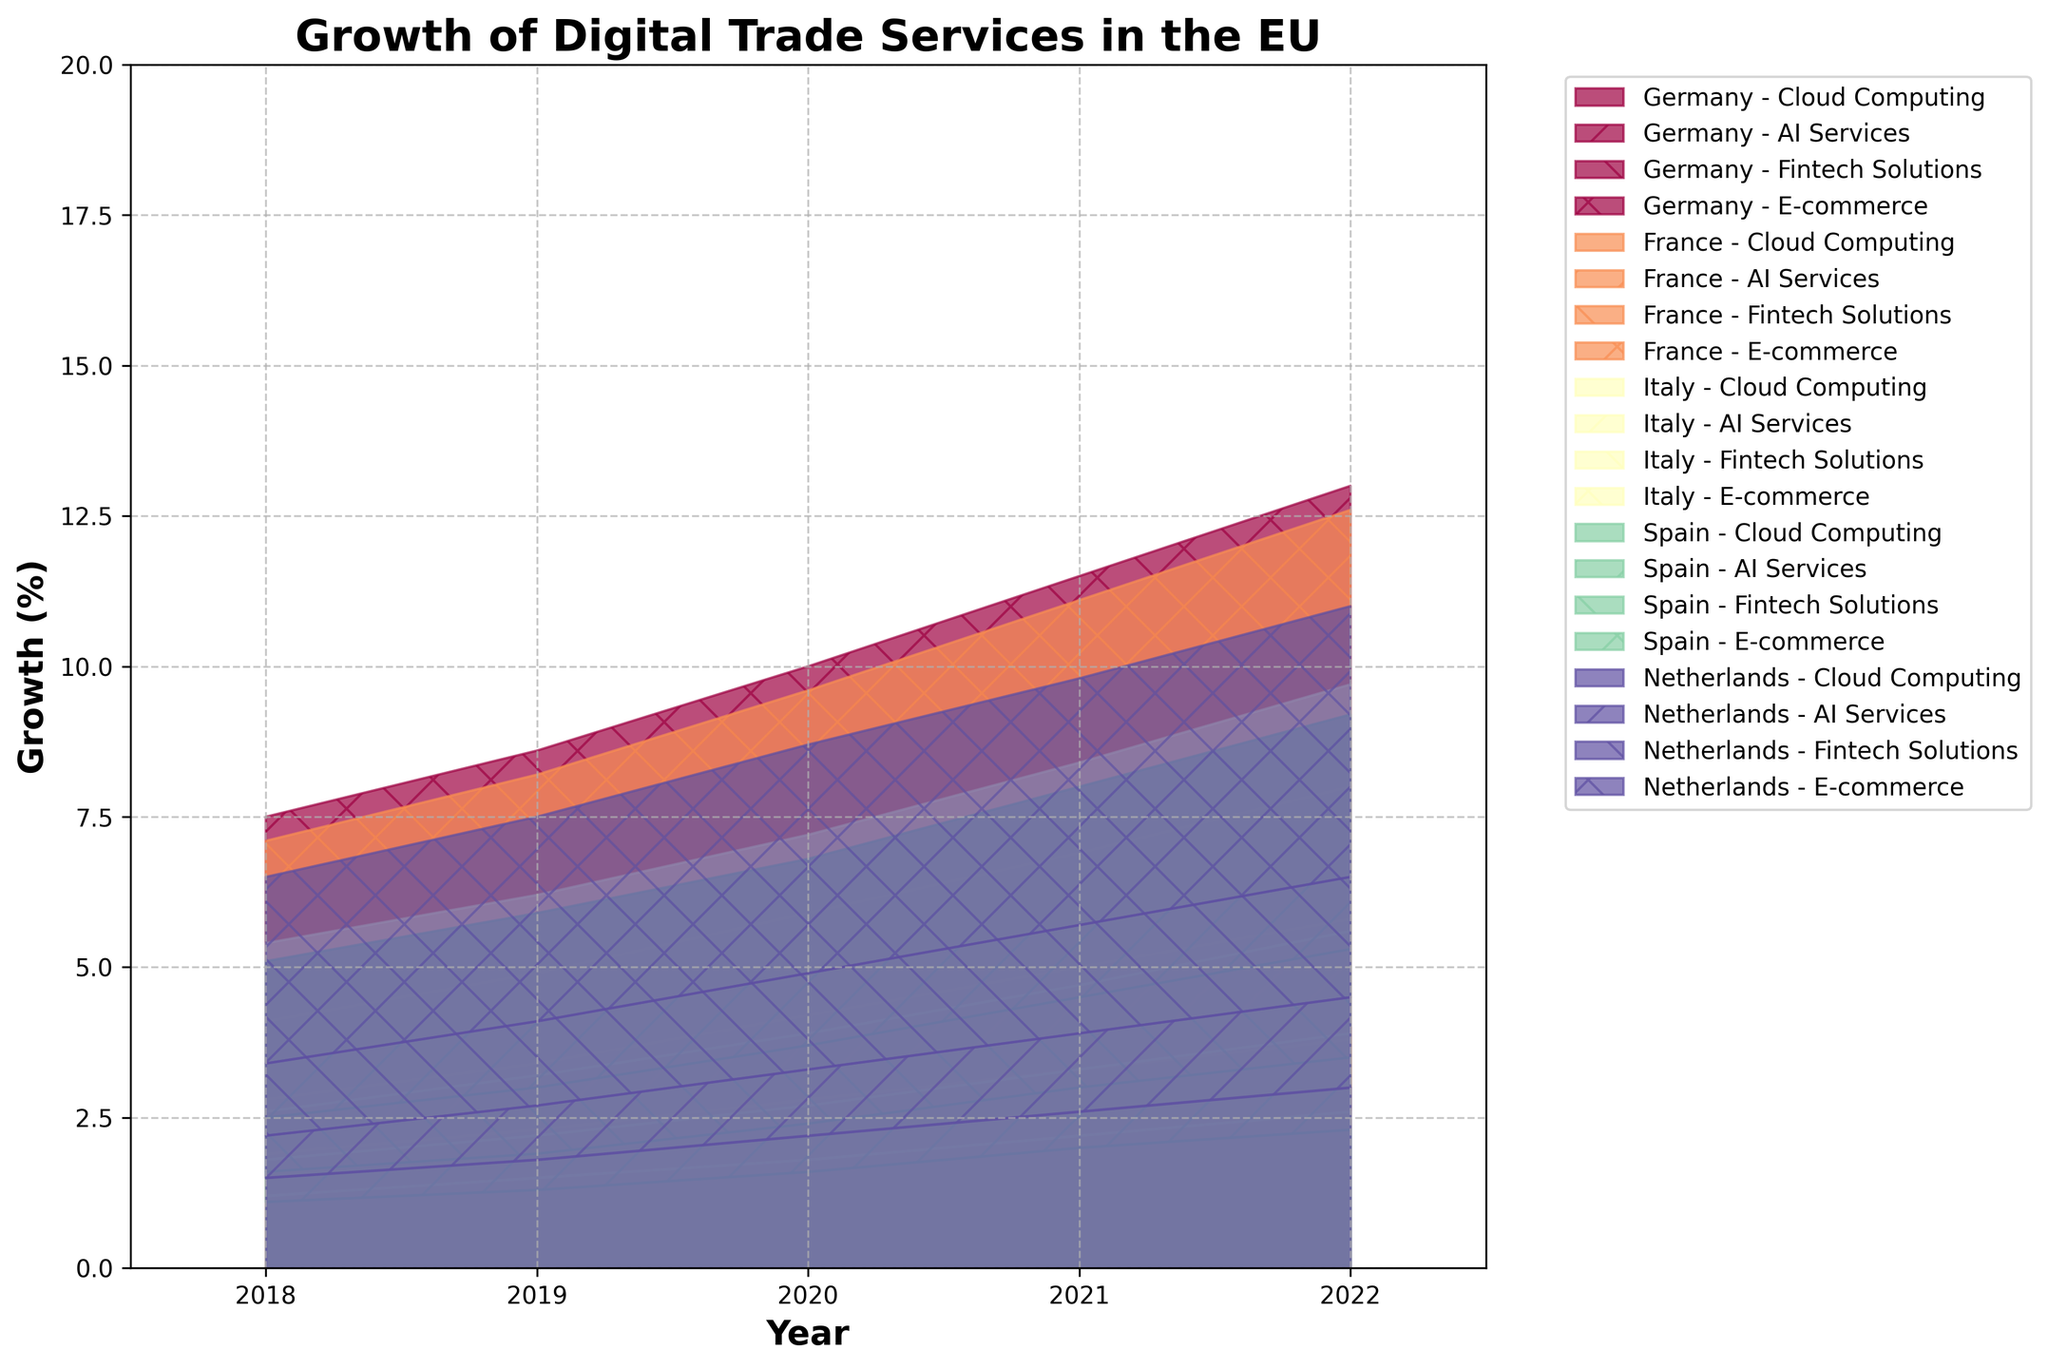What is the title of the figure? The title is prominently displayed at the top part of the figure.
Answer: Growth of Digital Trade Services in the EU Which country shows the highest growth in Cloud Computing in 2022? Look at the topmost segment in 2022 for all countries and find the tallest section corresponding to Cloud Computing.
Answer: Germany How do AI Services in Spain in 2018 compare to AI Services in the Netherlands in 2019? Compare the height of the area segment designated for AI Services for Spain in 2018 with that for the Netherlands in 2019.
Answer: Spain 2018 is lower What is the total percentage growth of Fintech Solutions across all countries in 2021? Sum up the values represented by the Fintech Solutions segments for all countries in 2021.
Answer: (2.0 + 1.9 + 1.4 + 1.5 + 1.8) = 8.6% Which digital trade service has the least growth in Italy over the years? Identify the digital trade service with the smallest area increase for Italy by observing each year's segment heights.
Answer: AI Services From 2018 to 2022, how does the growth in E-commerce in France progress? Observe the height of the E-commerce segment for France in each year and describe its increasing trend.
Answer: Increasing every year Which country shows the most balanced growth across all services in 2020? Assess each country's segments' heights for even distribution in 2020 and compare these distributions.
Answer: Netherlands What is the approximate cumulative percentage growth for Germany in 2020 across all digital services? Sum the heights of all segments (Cloud Computing, AI Services, Fintech Solutions, E-commerce) for Germany in 2020.
Answer: 3.0 + 1.3 + 1.8 + 3.9 = 10.0% How does Italy's growth in Fintech Solutions in 2019 compare to its growth in Cloud Computing in 2021? Compare the height segments of Fintech Solutions in 2019 and Cloud Computing in 2021 for Italy.
Answer: Cloud Computing in 2021 is higher What trend can be observed about AI Services' growth for all countries from 2018 to 2022? Observe the change in height of the AI Services segment over the years for each country to identify a trend.
Answer: Increasing for all countries 